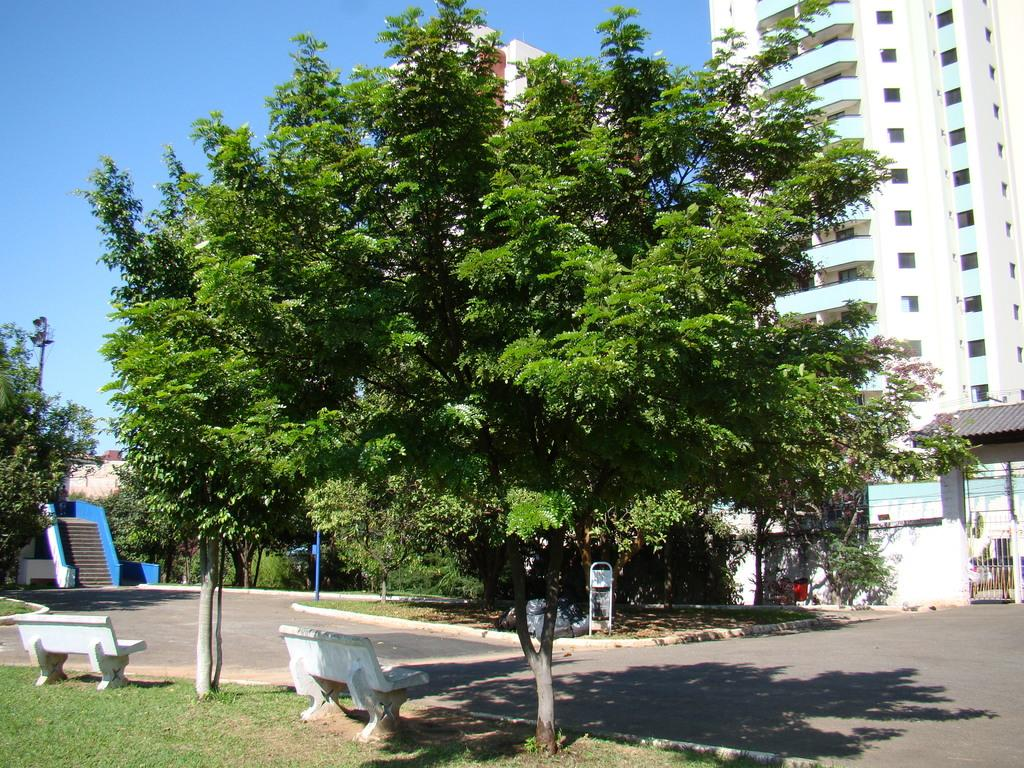What type of natural elements can be seen in the image? There are trees in the image. What type of man-made structures are present in the image? There are buildings, stairs, benches, poles, and a gate in the image. What is the purpose of the stairs in the image? The stairs provide access to different levels or areas in the image. What type of seating is available in the image? There are benches in the image for people to sit on. What is the purpose of the poles in the image? The poles may be used for support, signage, or other purposes. What is the purpose of the gate in the image? The gate may provide access control or serve as a boundary. What is visible at the bottom of the image? There is a road at the bottom of the image. What is visible at the top of the image? Sky is visible at the top of the image. What letter is written on the lettuce in the image? There is no lettuce present in the image, and therefore no letter can be written on it. 